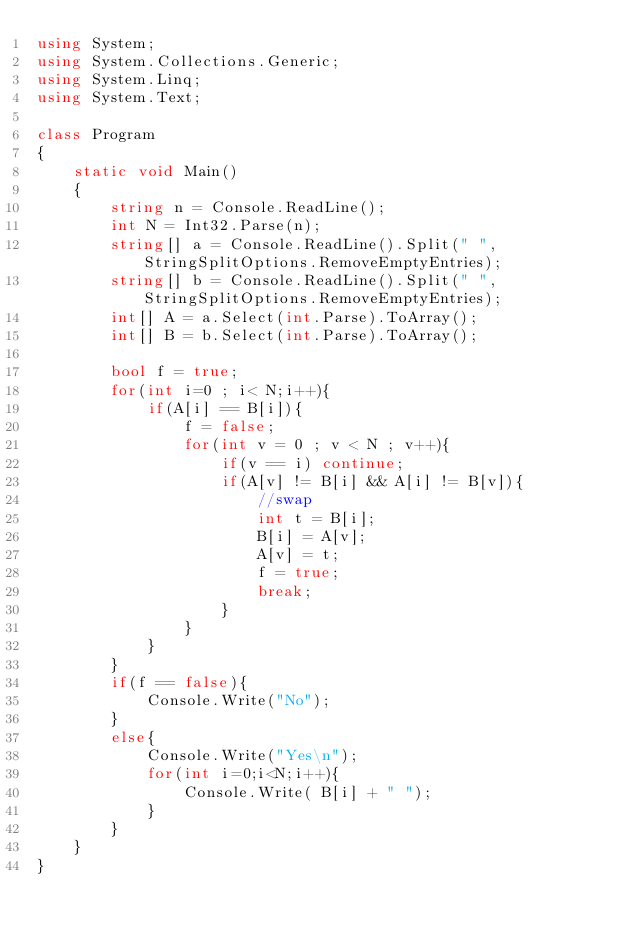<code> <loc_0><loc_0><loc_500><loc_500><_C#_>using System;
using System.Collections.Generic;
using System.Linq;
using System.Text;

class Program
{
    static void Main()
    {
        string n = Console.ReadLine();
        int N = Int32.Parse(n);
        string[] a = Console.ReadLine().Split(" ",StringSplitOptions.RemoveEmptyEntries);
        string[] b = Console.ReadLine().Split(" ",StringSplitOptions.RemoveEmptyEntries);
        int[] A = a.Select(int.Parse).ToArray();
        int[] B = b.Select(int.Parse).ToArray();
        
        bool f = true;
        for(int i=0 ; i< N;i++){
            if(A[i] == B[i]){
                f = false;
                for(int v = 0 ; v < N ; v++){
                    if(v == i) continue;
                    if(A[v] != B[i] && A[i] != B[v]){
                        //swap
                        int t = B[i];
                        B[i] = A[v];
                        A[v] = t;
                        f = true;
                        break; 
                    }
                }
            }
        }
        if(f == false){
            Console.Write("No");
        }
        else{
            Console.Write("Yes\n");
            for(int i=0;i<N;i++){
                Console.Write( B[i] + " ");
            }
        }
    }
}
</code> 